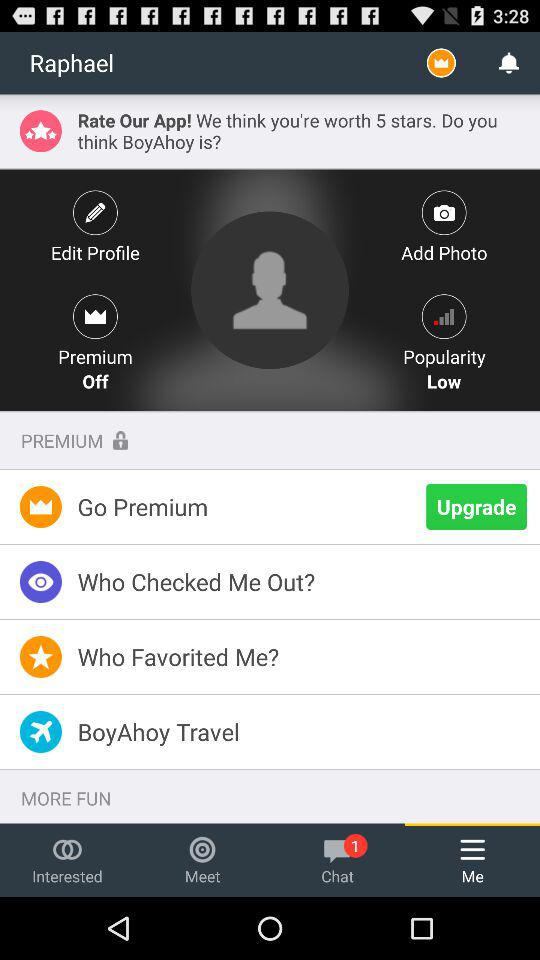How many unread chats are there? There is 1 unread chat. 